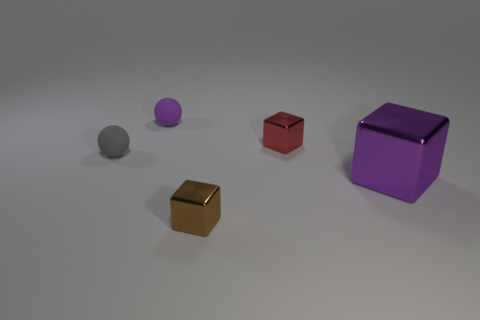Add 3 brown metal objects. How many objects exist? 8 Subtract all balls. How many objects are left? 3 Subtract 0 cyan cylinders. How many objects are left? 5 Subtract all tiny red metallic blocks. Subtract all purple balls. How many objects are left? 3 Add 4 shiny cubes. How many shiny cubes are left? 7 Add 2 gray balls. How many gray balls exist? 3 